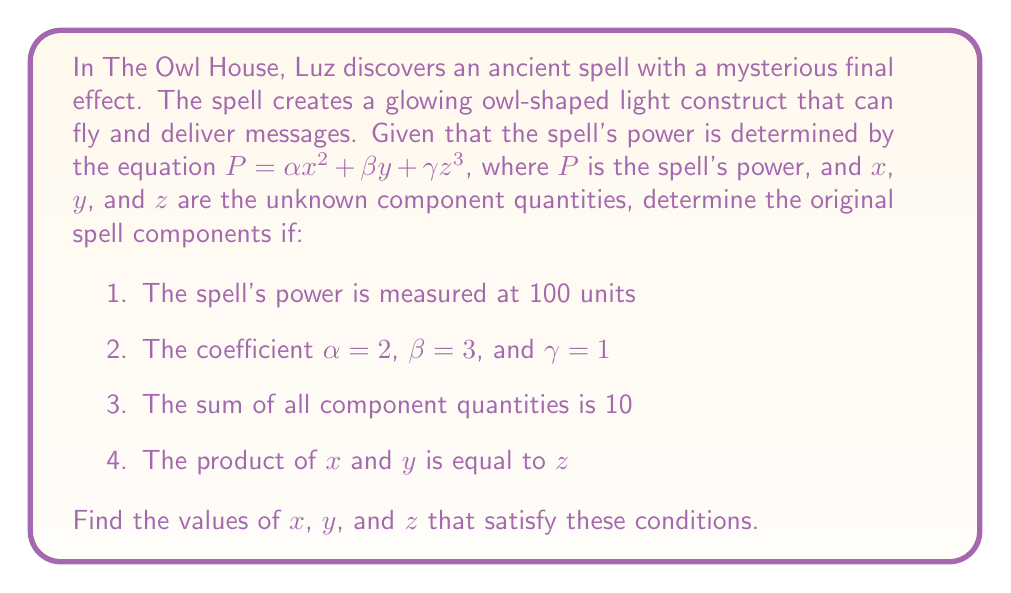Solve this math problem. Let's approach this step-by-step:

1) We have the equation for the spell's power:
   $P = \alpha x^2 + \beta y + \gamma z^3$

2) Substituting the known values:
   $100 = 2x^2 + 3y + z^3$

3) We also know that:
   $x + y + z = 10$ (sum of components)
   $xy = z$ (product of x and y equals z)

4) Let's substitute $z = xy$ into the power equation:
   $100 = 2x^2 + 3y + (xy)^3$

5) Now we have a system of two equations:
   $100 = 2x^2 + 3y + (xy)^3$
   $10 = x + y + xy$

6) From the second equation, we can express y:
   $y = \frac{10 - x}{1 + x}$

7) Substituting this into the first equation:
   $100 = 2x^2 + 3(\frac{10 - x}{1 + x}) + (x(\frac{10 - x}{1 + x}))^3$

8) This equation can be solved numerically. Using a computer algebra system or numerical methods, we find:
   $x \approx 2$

9) Substituting back:
   $y = \frac{10 - 2}{1 + 2} = \frac{8}{3} \approx 2.67$
   $z = xy = 2 * \frac{8}{3} = \frac{16}{3} \approx 5.33$

10) We can verify:
    $2 + \frac{8}{3} + \frac{16}{3} = 10$
    $2 * \frac{8}{3} = \frac{16}{3}$
    $100 \approx 2(2^2) + 3(\frac{8}{3}) + (\frac{16}{3})^3$

Therefore, the original spell components are approximately $x = 2$, $y = \frac{8}{3}$, and $z = \frac{16}{3}$.
Answer: $x = 2$, $y = \frac{8}{3}$, $z = \frac{16}{3}$ 